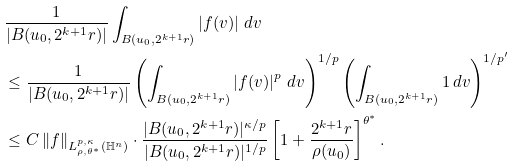<formula> <loc_0><loc_0><loc_500><loc_500>& \frac { 1 } { | B ( u _ { 0 } , 2 ^ { k + 1 } r ) | } \int _ { B ( u _ { 0 } , 2 ^ { k + 1 } r ) } \left | f ( v ) \right | \, d v \\ & \leq \frac { 1 } { | B ( u _ { 0 } , 2 ^ { k + 1 } r ) | } \left ( \int _ { B ( u _ { 0 } , 2 ^ { k + 1 } r ) } \left | f ( v ) \right | ^ { p } \, d v \right ) ^ { 1 / p } \left ( \int _ { B ( u _ { 0 } , 2 ^ { k + 1 } r ) } 1 \, d v \right ) ^ { 1 / { p ^ { \prime } } } \\ & \leq C \left \| f \right \| _ { L ^ { p , \kappa } _ { \rho , \theta ^ { * } } ( \mathbb { H } ^ { n } ) } \cdot \frac { | B ( u _ { 0 } , 2 ^ { k + 1 } r ) | ^ { { \kappa } / p } } { | B ( u _ { 0 } , 2 ^ { k + 1 } r ) | ^ { 1 / p } } \left [ 1 + \frac { 2 ^ { k + 1 } r } { \rho ( u _ { 0 } ) } \right ] ^ { \theta ^ { * } } .</formula> 